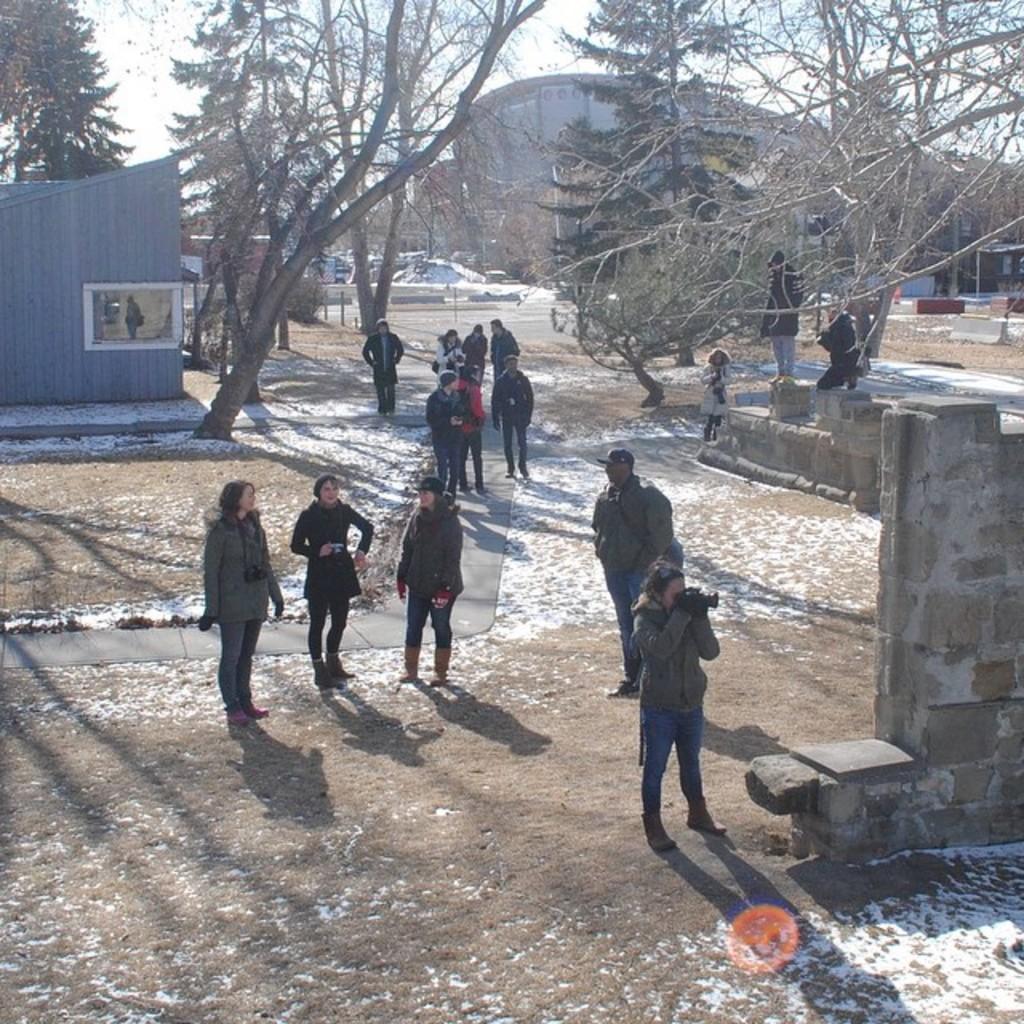Describe this image in one or two sentences. In this image we can see some people and among them few people holding some objects in their hands and we can see a shed on the left side of the image. There is a wall and we can see some trees and there is a building in the background and we can see the sky. 